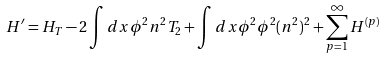Convert formula to latex. <formula><loc_0><loc_0><loc_500><loc_500>H ^ { \prime } = H _ { T } - 2 \int d x \phi ^ { 2 } n ^ { 2 } T _ { 2 } + \int d x \phi ^ { 2 } \phi ^ { 2 } ( n ^ { 2 } ) ^ { 2 } + \sum _ { p = 1 } ^ { \infty } H ^ { ( p ) }</formula> 